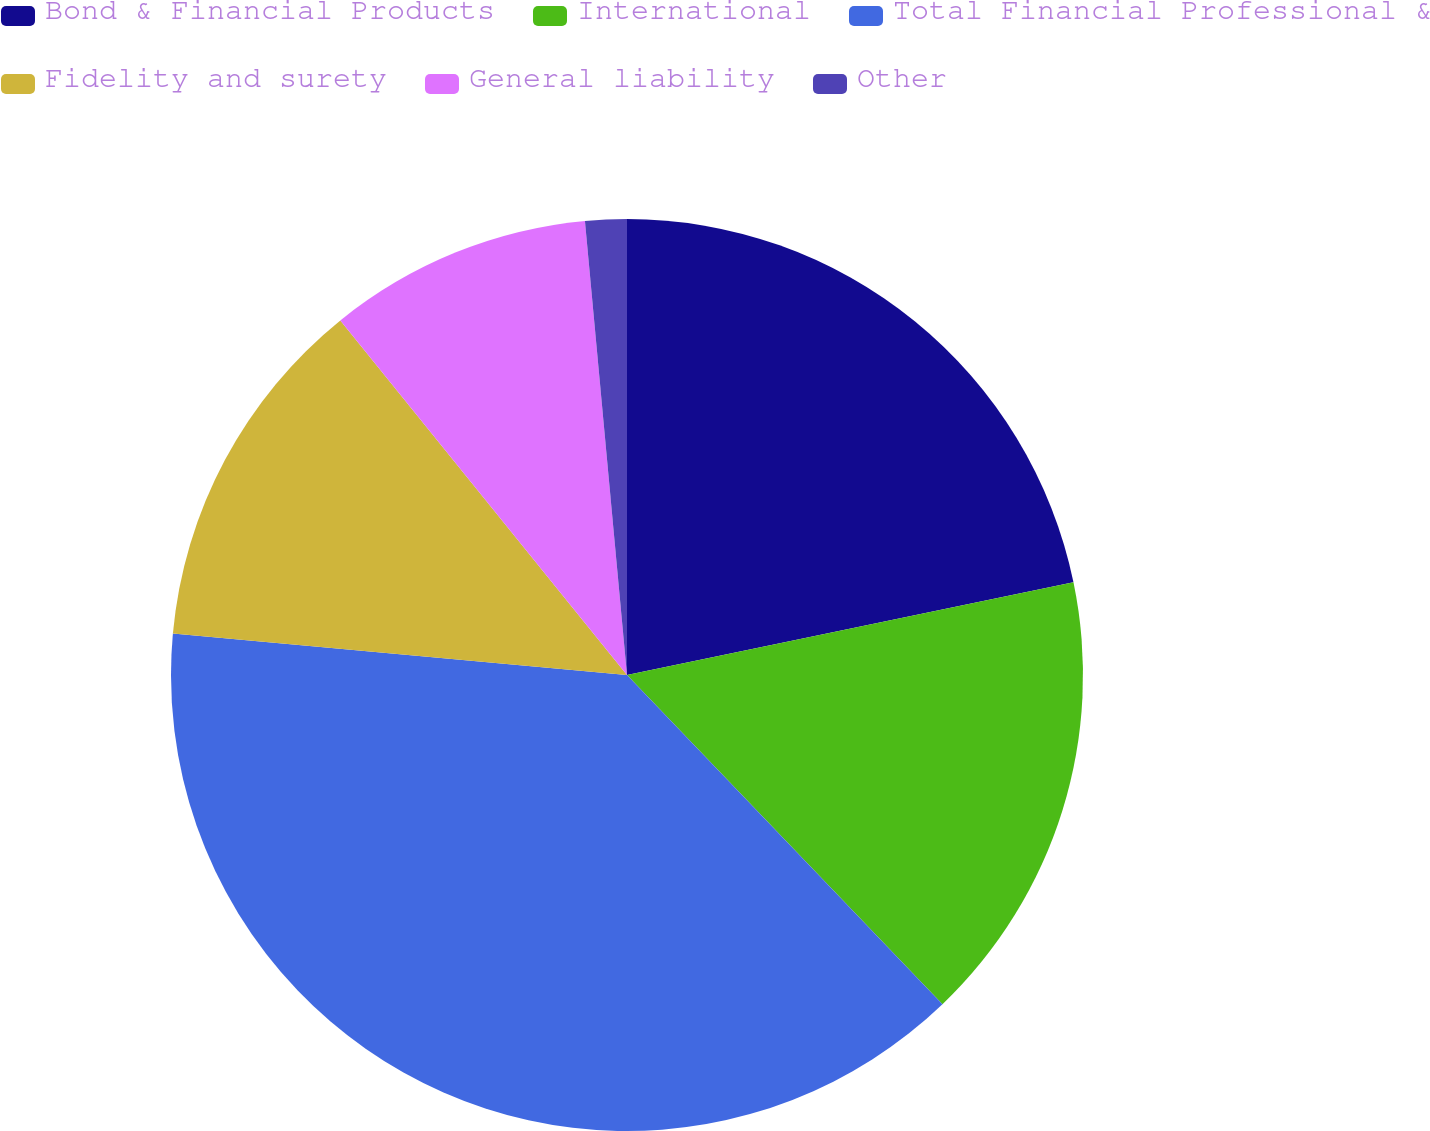Convert chart to OTSL. <chart><loc_0><loc_0><loc_500><loc_500><pie_chart><fcel>Bond & Financial Products<fcel>International<fcel>Total Financial Professional &<fcel>Fidelity and surety<fcel>General liability<fcel>Other<nl><fcel>21.74%<fcel>16.1%<fcel>38.61%<fcel>12.73%<fcel>9.35%<fcel>1.47%<nl></chart> 